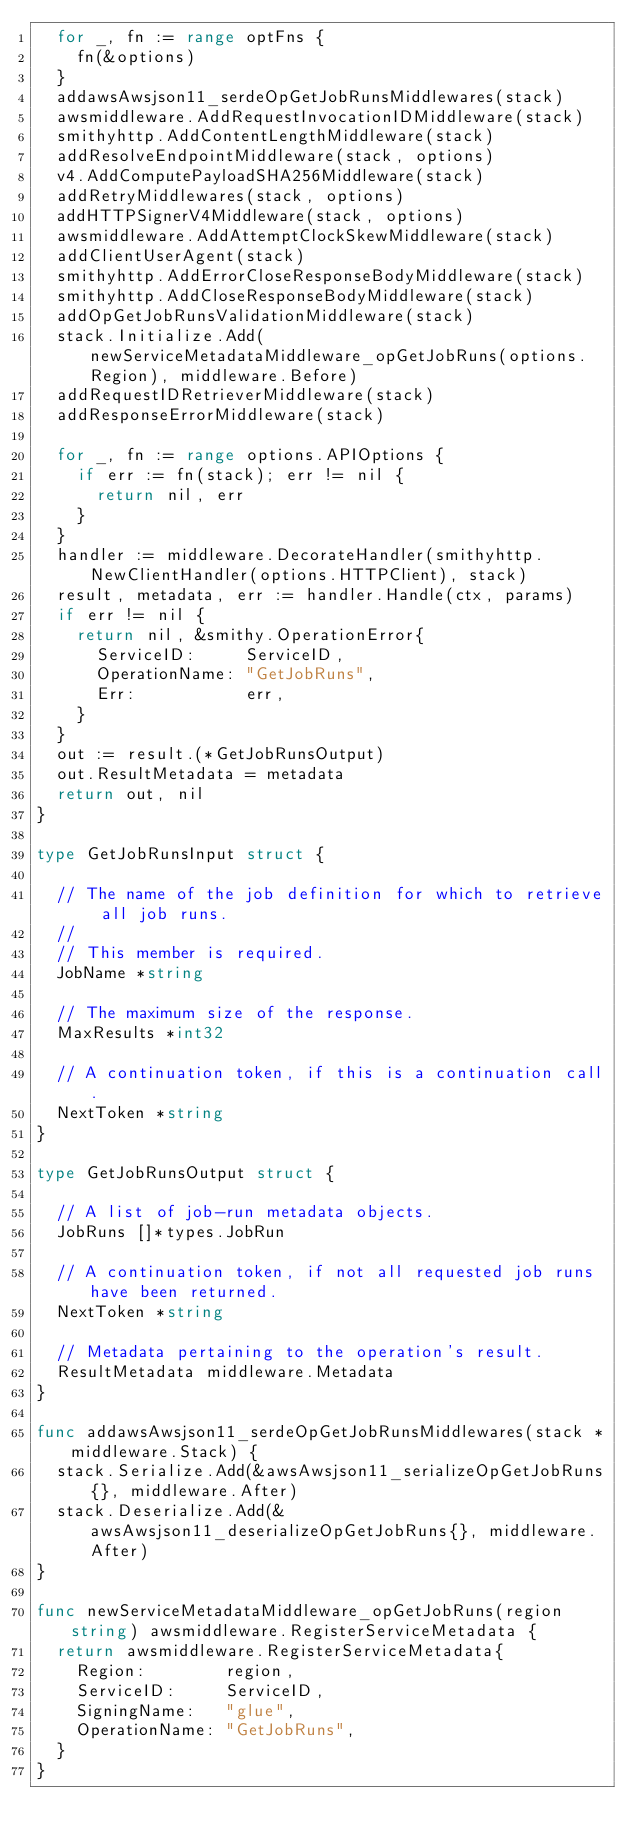Convert code to text. <code><loc_0><loc_0><loc_500><loc_500><_Go_>	for _, fn := range optFns {
		fn(&options)
	}
	addawsAwsjson11_serdeOpGetJobRunsMiddlewares(stack)
	awsmiddleware.AddRequestInvocationIDMiddleware(stack)
	smithyhttp.AddContentLengthMiddleware(stack)
	addResolveEndpointMiddleware(stack, options)
	v4.AddComputePayloadSHA256Middleware(stack)
	addRetryMiddlewares(stack, options)
	addHTTPSignerV4Middleware(stack, options)
	awsmiddleware.AddAttemptClockSkewMiddleware(stack)
	addClientUserAgent(stack)
	smithyhttp.AddErrorCloseResponseBodyMiddleware(stack)
	smithyhttp.AddCloseResponseBodyMiddleware(stack)
	addOpGetJobRunsValidationMiddleware(stack)
	stack.Initialize.Add(newServiceMetadataMiddleware_opGetJobRuns(options.Region), middleware.Before)
	addRequestIDRetrieverMiddleware(stack)
	addResponseErrorMiddleware(stack)

	for _, fn := range options.APIOptions {
		if err := fn(stack); err != nil {
			return nil, err
		}
	}
	handler := middleware.DecorateHandler(smithyhttp.NewClientHandler(options.HTTPClient), stack)
	result, metadata, err := handler.Handle(ctx, params)
	if err != nil {
		return nil, &smithy.OperationError{
			ServiceID:     ServiceID,
			OperationName: "GetJobRuns",
			Err:           err,
		}
	}
	out := result.(*GetJobRunsOutput)
	out.ResultMetadata = metadata
	return out, nil
}

type GetJobRunsInput struct {

	// The name of the job definition for which to retrieve all job runs.
	//
	// This member is required.
	JobName *string

	// The maximum size of the response.
	MaxResults *int32

	// A continuation token, if this is a continuation call.
	NextToken *string
}

type GetJobRunsOutput struct {

	// A list of job-run metadata objects.
	JobRuns []*types.JobRun

	// A continuation token, if not all requested job runs have been returned.
	NextToken *string

	// Metadata pertaining to the operation's result.
	ResultMetadata middleware.Metadata
}

func addawsAwsjson11_serdeOpGetJobRunsMiddlewares(stack *middleware.Stack) {
	stack.Serialize.Add(&awsAwsjson11_serializeOpGetJobRuns{}, middleware.After)
	stack.Deserialize.Add(&awsAwsjson11_deserializeOpGetJobRuns{}, middleware.After)
}

func newServiceMetadataMiddleware_opGetJobRuns(region string) awsmiddleware.RegisterServiceMetadata {
	return awsmiddleware.RegisterServiceMetadata{
		Region:        region,
		ServiceID:     ServiceID,
		SigningName:   "glue",
		OperationName: "GetJobRuns",
	}
}
</code> 